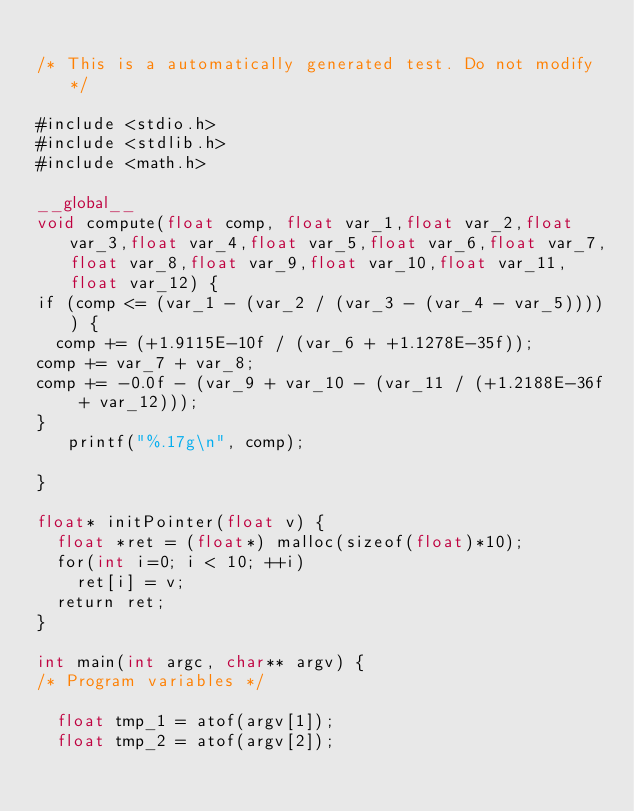Convert code to text. <code><loc_0><loc_0><loc_500><loc_500><_Cuda_>
/* This is a automatically generated test. Do not modify */

#include <stdio.h>
#include <stdlib.h>
#include <math.h>

__global__
void compute(float comp, float var_1,float var_2,float var_3,float var_4,float var_5,float var_6,float var_7,float var_8,float var_9,float var_10,float var_11,float var_12) {
if (comp <= (var_1 - (var_2 / (var_3 - (var_4 - var_5))))) {
  comp += (+1.9115E-10f / (var_6 + +1.1278E-35f));
comp += var_7 + var_8;
comp += -0.0f - (var_9 + var_10 - (var_11 / (+1.2188E-36f + var_12)));
}
   printf("%.17g\n", comp);

}

float* initPointer(float v) {
  float *ret = (float*) malloc(sizeof(float)*10);
  for(int i=0; i < 10; ++i)
    ret[i] = v;
  return ret;
}

int main(int argc, char** argv) {
/* Program variables */

  float tmp_1 = atof(argv[1]);
  float tmp_2 = atof(argv[2]);</code> 